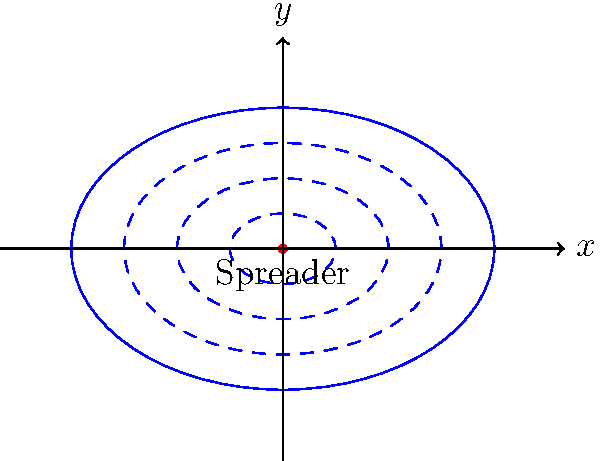A rotating fertilizer spreader is modeled using concentric ellipses to represent the distribution pattern. The outermost ellipse has a semi-major axis of 6 meters and a semi-minor axis of 4 meters. If a farmer wants to ensure that at least 75% of the field receives fertilizer, what is the area (in square meters) that will be covered by the spreader in a single position? To solve this problem, we'll follow these steps:

1) The general equation of an ellipse is $\frac{x^2}{a^2} + \frac{y^2}{b^2} = 1$, where $a$ is the semi-major axis and $b$ is the semi-minor axis.

2) We're given that the outermost ellipse has $a = 6$ and $b = 4$.

3) To cover 75% of the field, we need to find the area of an ellipse with axes that are 75% of the original:
   $a_{75\%} = 6 \times 0.75 = 4.5$ meters
   $b_{75\%} = 4 \times 0.75 = 3$ meters

4) The area of an ellipse is given by the formula: $A = \pi ab$

5) Substituting our values:
   $A = \pi \times 4.5 \times 3 = 13.5\pi$ square meters

6) Calculate the final value:
   $13.5\pi \approx 42.41$ square meters

Therefore, the area covered by the spreader to ensure 75% coverage is approximately 42.41 square meters.
Answer: $42.41$ square meters 